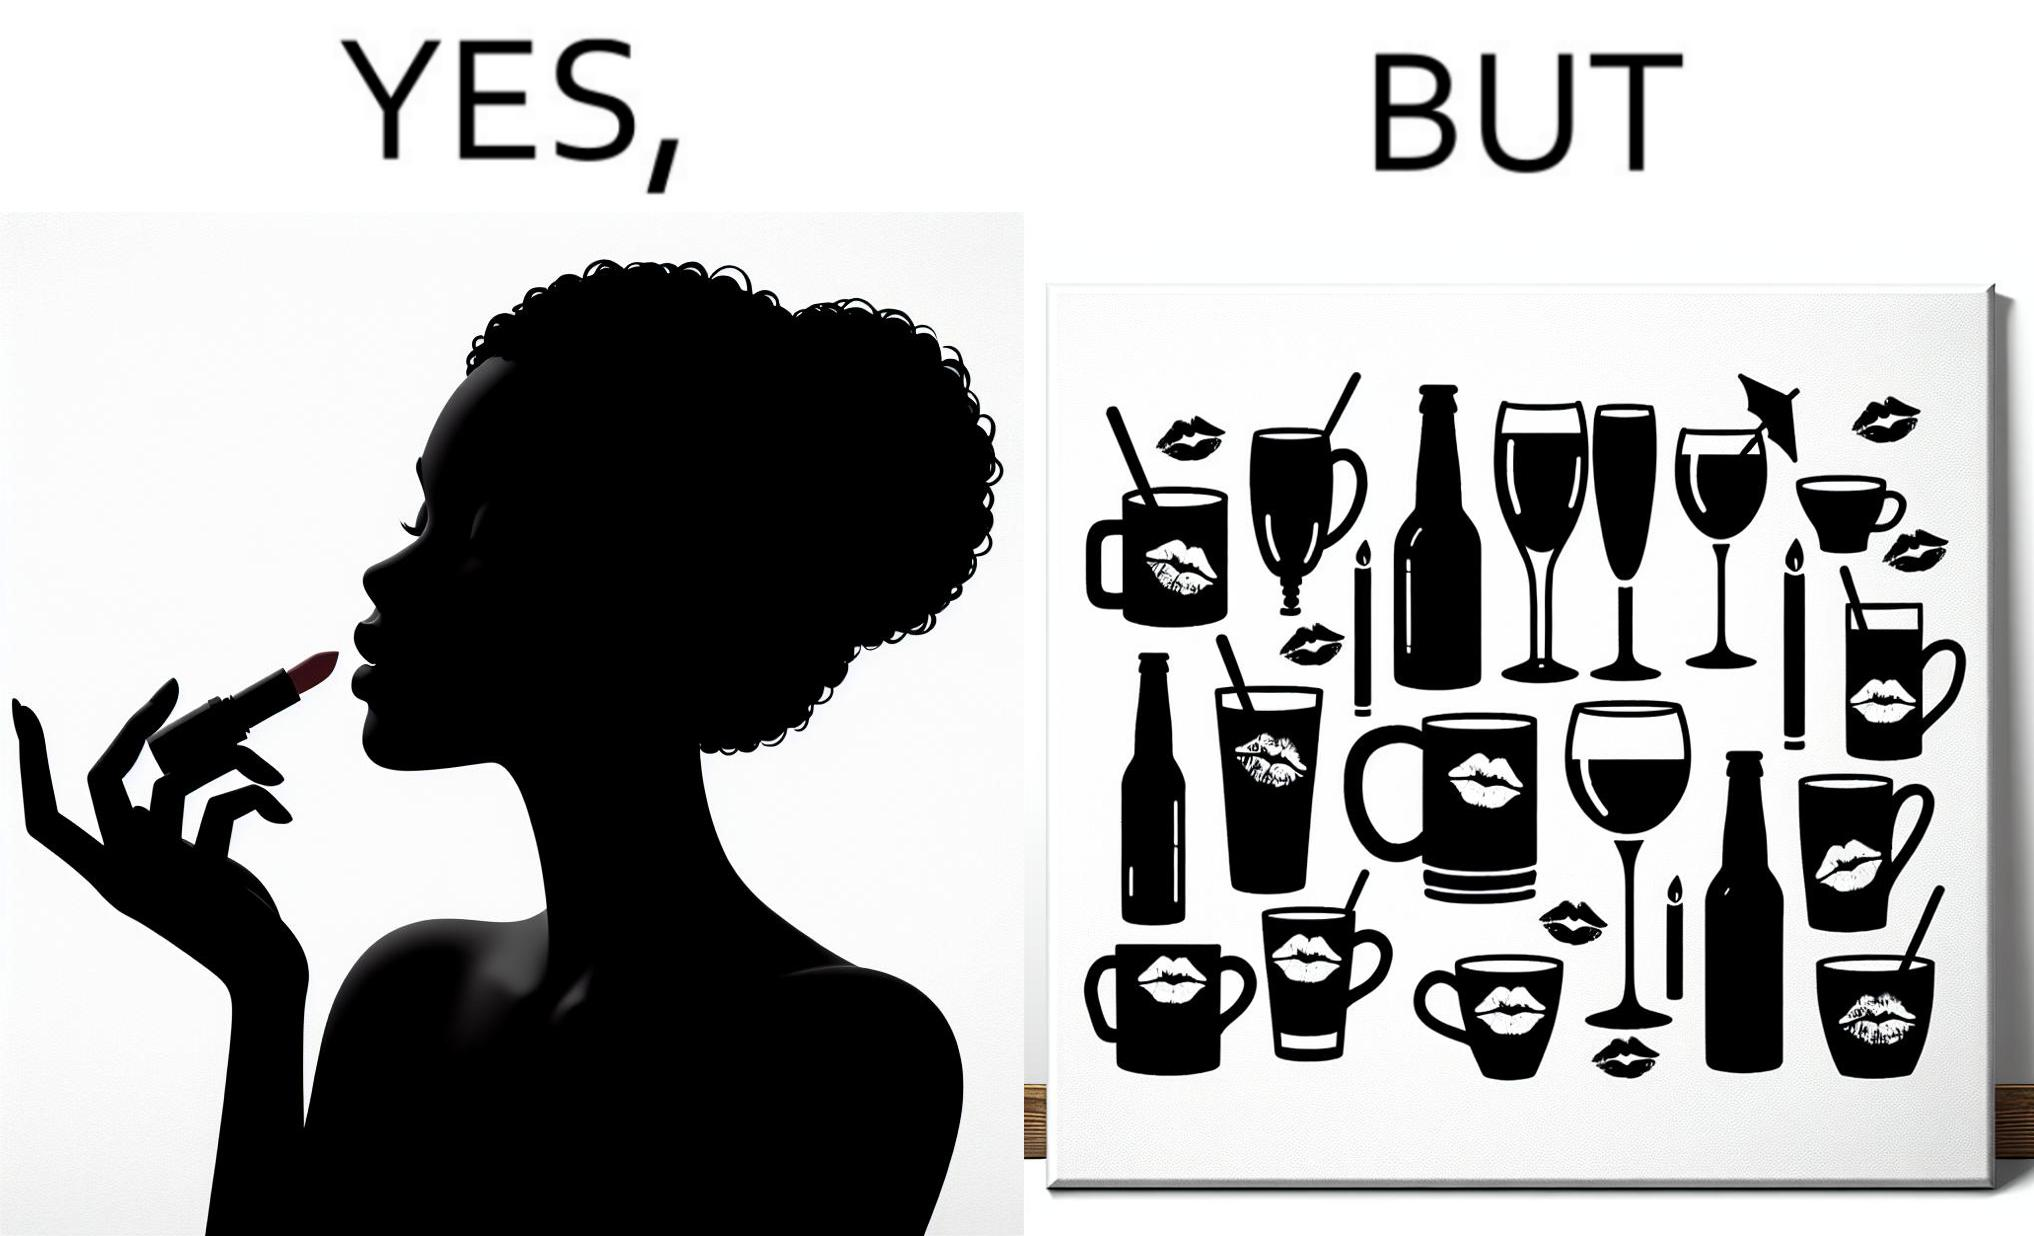What does this image depict? The image is ironic, because the left image suggest that a person applies lipsticks on their lips to make their lips look attractive or to keep them hydrated but on the contrary it gets sticked to the glasses or mugs and gets wasted 